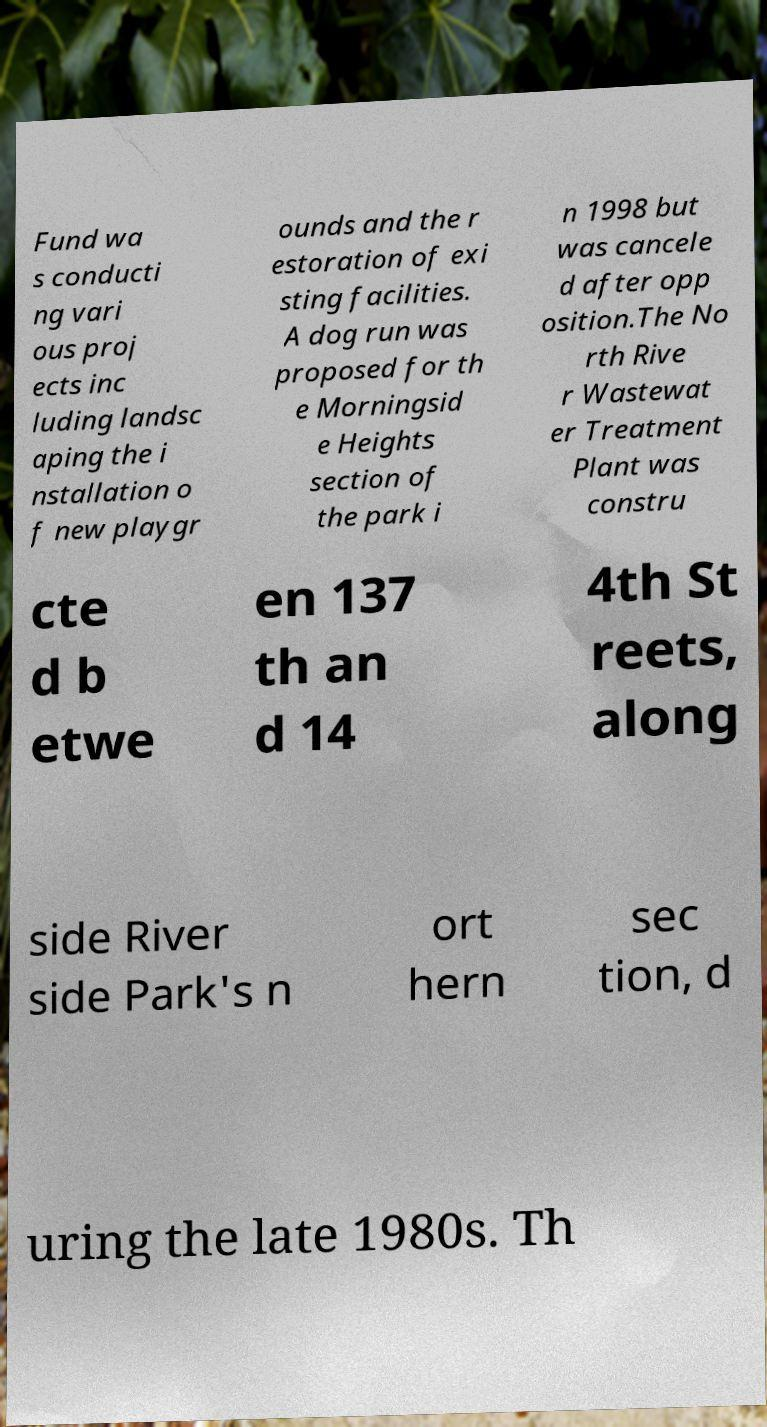Please identify and transcribe the text found in this image. Fund wa s conducti ng vari ous proj ects inc luding landsc aping the i nstallation o f new playgr ounds and the r estoration of exi sting facilities. A dog run was proposed for th e Morningsid e Heights section of the park i n 1998 but was cancele d after opp osition.The No rth Rive r Wastewat er Treatment Plant was constru cte d b etwe en 137 th an d 14 4th St reets, along side River side Park's n ort hern sec tion, d uring the late 1980s. Th 